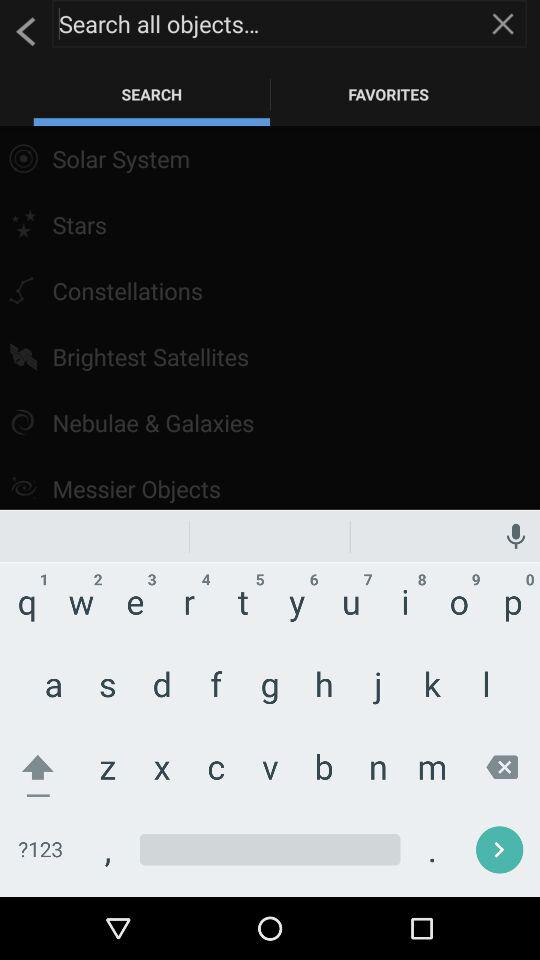What is the name of the application? The name of the application is "SkyView". 